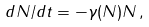<formula> <loc_0><loc_0><loc_500><loc_500>d N / d t = - \gamma ( N ) N \, ,</formula> 